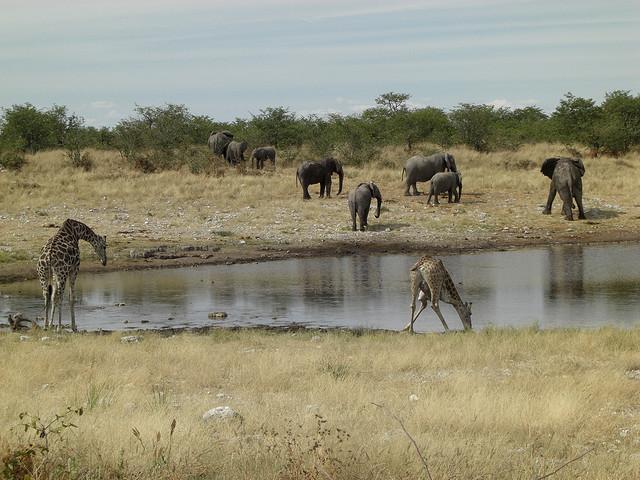Where are the elephants and giraffes?
Concise answer only. At waterhole. How many animals are present?
Concise answer only. 10. What type of day is this?
Keep it brief. Sunny. 